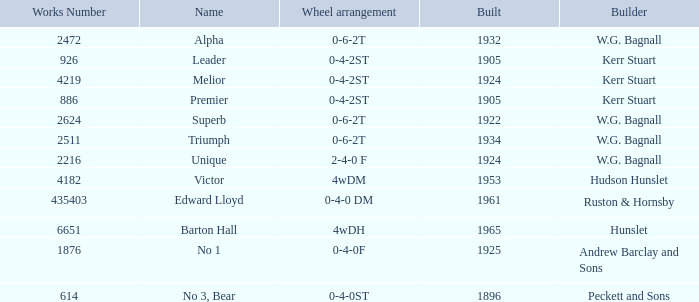What is the work number for Victor? 4182.0. 